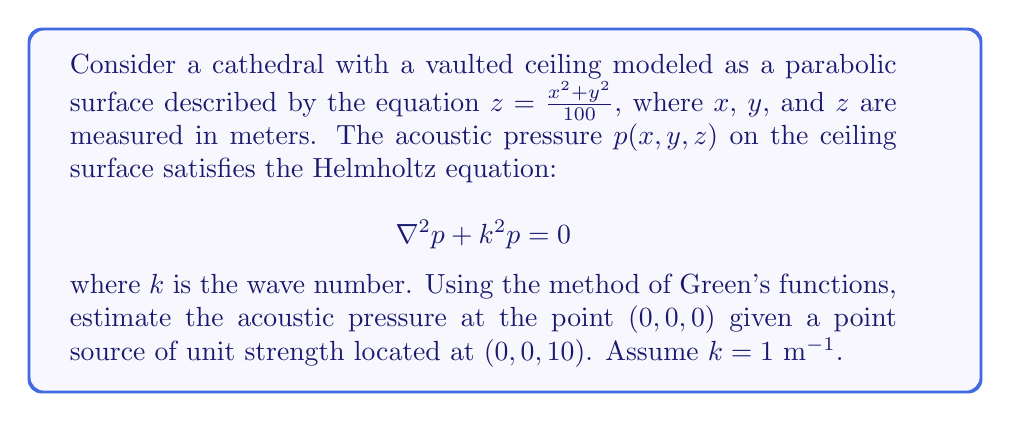Show me your answer to this math problem. To solve this problem, we'll follow these steps:

1) The Green's function for the Helmholtz equation in 3D is:

   $$G(\mathbf{r}, \mathbf{r}') = \frac{e^{ik|\mathbf{r} - \mathbf{r}'|}}{4\pi|\mathbf{r} - \mathbf{r}'|}$$

2) The integral equation for the acoustic pressure is:

   $$p(\mathbf{r}) = \int_S \left[G(\mathbf{r}, \mathbf{r}') \frac{\partial p(\mathbf{r}')}{\partial n'} - p(\mathbf{r}') \frac{\partial G(\mathbf{r}, \mathbf{r}')}{\partial n'}\right] dS'$$

   where $S$ is the ceiling surface and $n'$ is the normal to the surface.

3) For a point source at $\mathbf{r}_s = (0,0,10)$, we can approximate:

   $$p(\mathbf{r}) \approx G(\mathbf{r}, \mathbf{r}_s) = \frac{e^{ik|\mathbf{r} - \mathbf{r}_s|}}{4\pi|\mathbf{r} - \mathbf{r}_s|}$$

4) At the point of interest $\mathbf{r} = (0,0,0)$:

   $$p(0,0,0) \approx \frac{e^{ik||(0,0,0) - (0,0,10)||}}{4\pi||(0,0,0) - (0,0,10)||}$$

5) Calculating:
   
   $$||(0,0,0) - (0,0,10)|| = 10$$

   $$p(0,0,0) \approx \frac{e^{i(1)(10)}}{4\pi(10)} = \frac{e^{10i}}{40\pi}$$

6) Using Euler's formula, $e^{10i} = \cos(10) + i\sin(10)$:

   $$p(0,0,0) \approx \frac{\cos(10) + i\sin(10)}{40\pi}$$

7) This can be expressed in polar form:

   $$p(0,0,0) \approx \frac{1}{40\pi}(\cos(10) + i\sin(10)) \approx 0.00796 \angle 10 \text{ rad}$$
Answer: $0.00796 \angle 10 \text{ rad}$ 